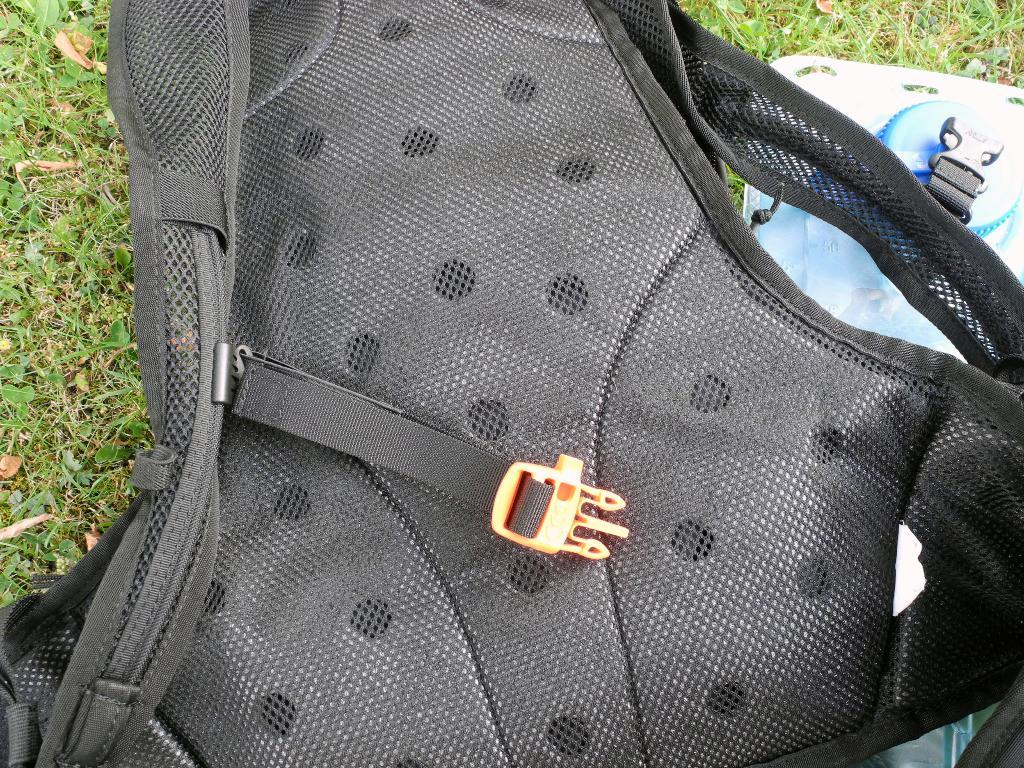What object is on the ground in the image? There is a bag on the ground in the image. What is the color of the ground in the image? The ground is black in color. What is the name of the jellyfish swimming in the image? There is no jellyfish present in the image; it only features a bag on the ground. 